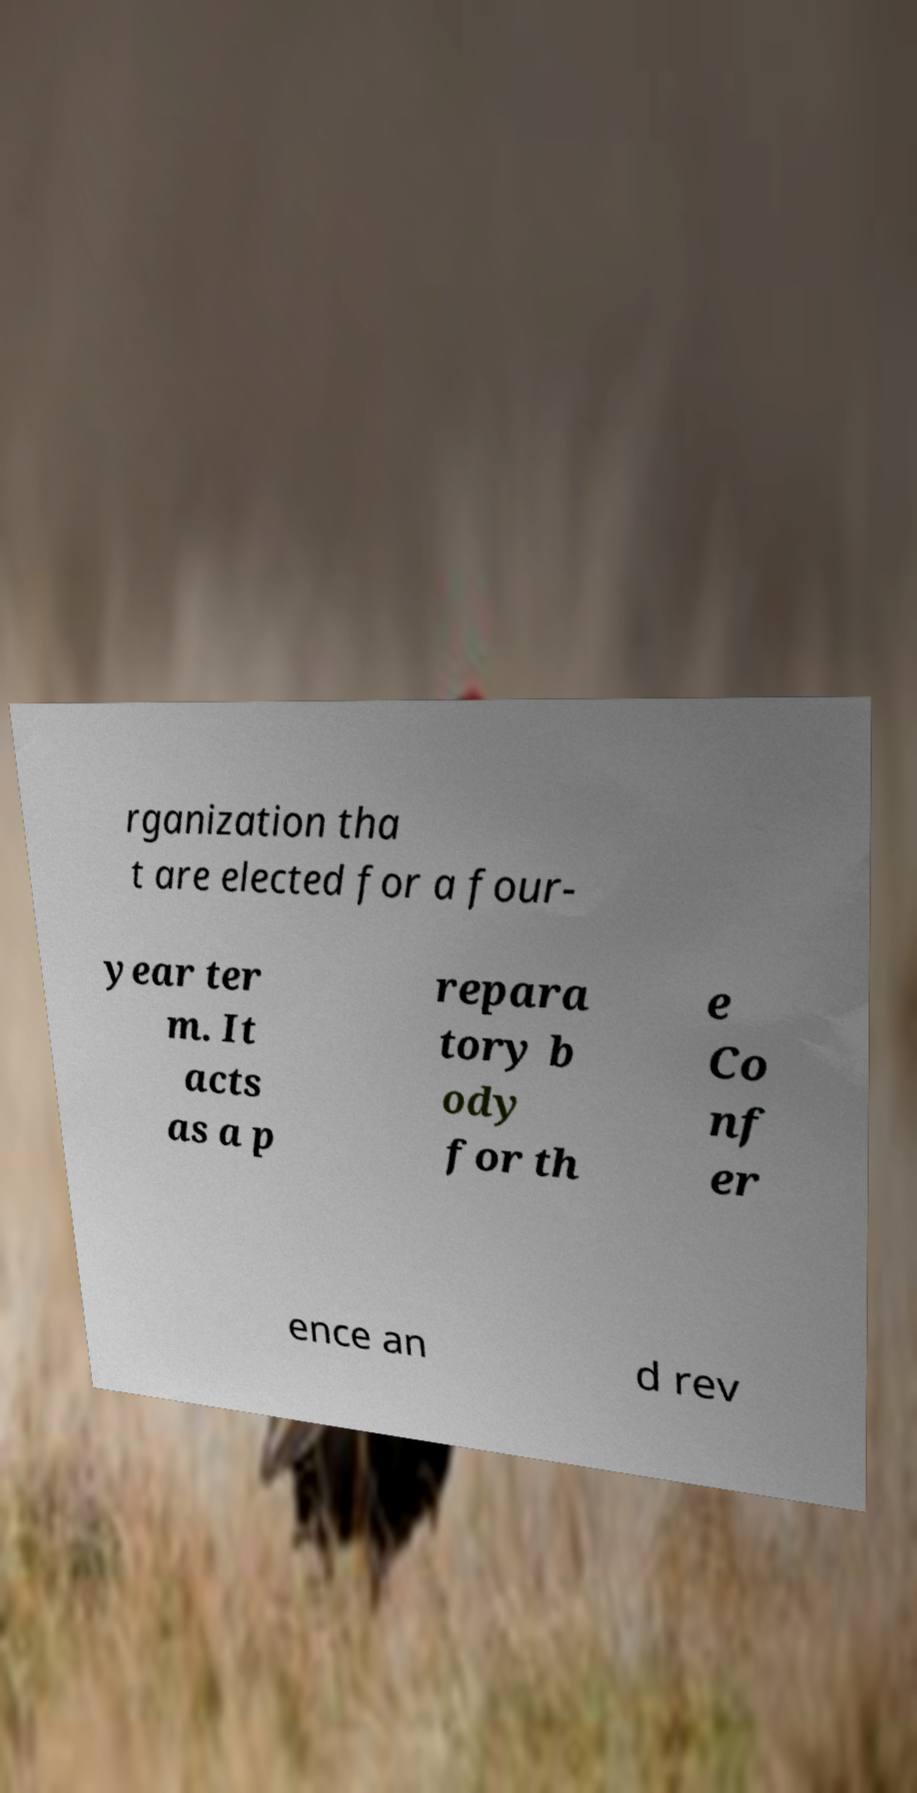What messages or text are displayed in this image? I need them in a readable, typed format. rganization tha t are elected for a four- year ter m. It acts as a p repara tory b ody for th e Co nf er ence an d rev 